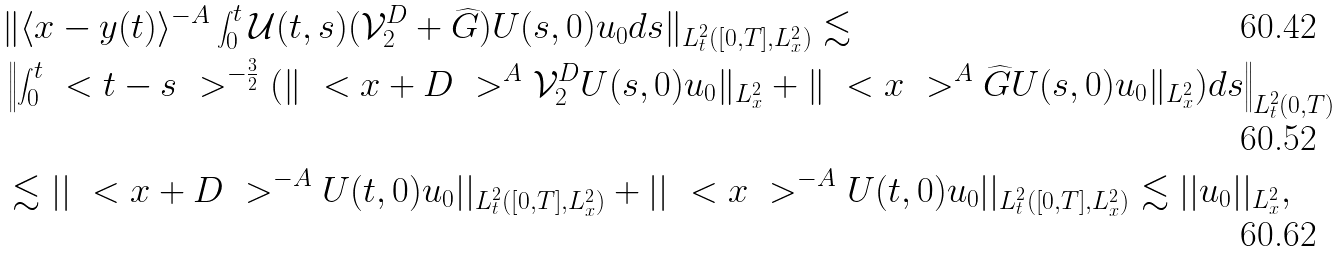Convert formula to latex. <formula><loc_0><loc_0><loc_500><loc_500>& \| \langle x - y ( t ) \rangle ^ { - A } \int _ { 0 } ^ { t } \mathcal { U } ( t , s ) ( \mathcal { V } _ { 2 } ^ { D } + \widehat { G } ) U ( s , 0 ) u _ { 0 } d s \| _ { L ^ { 2 } _ { t } ( [ 0 , T ] , L ^ { 2 } _ { x } ) } \lesssim \\ & \left \| \int _ { 0 } ^ { t } \ < t - s \ > ^ { - \frac { 3 } { 2 } } ( \| \ < x + D \ > ^ { A } \mathcal { V } _ { 2 } ^ { D } U ( s , 0 ) u _ { 0 } \| _ { L ^ { 2 } _ { x } } + \| \ < x \ > ^ { A } \widehat { G } U ( s , 0 ) u _ { 0 } \| _ { L ^ { 2 } _ { x } } ) d s \right \| _ { L ^ { 2 } _ { t } ( 0 , T ) } \\ & \lesssim | | \ < x + D \ > ^ { - A } U ( t , 0 ) u _ { 0 } | | _ { L ^ { 2 } _ { t } ( [ 0 , T ] , L ^ { 2 } _ { x } ) } + | | \ < x \ > ^ { - A } U ( t , 0 ) u _ { 0 } | | _ { L ^ { 2 } _ { t } ( [ 0 , T ] , L ^ { 2 } _ { x } ) } \lesssim | | u _ { 0 } | | _ { L ^ { 2 } _ { x } } ,</formula> 